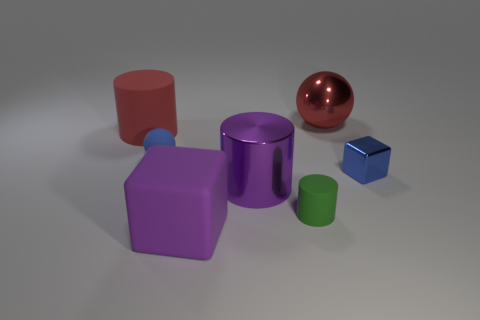Is the material of the big red cylinder the same as the blue block that is behind the big purple rubber thing?
Give a very brief answer. No. What number of objects are blue objects to the left of the large metallic ball or blue objects that are to the left of the big purple metal thing?
Your answer should be very brief. 1. What number of other objects are the same color as the big cube?
Offer a terse response. 1. Are there more green matte cylinders that are to the left of the small sphere than tiny matte cylinders that are on the right side of the small green rubber cylinder?
Your answer should be compact. No. Is there anything else that is the same size as the blue sphere?
Your answer should be very brief. Yes. How many cubes are either small things or tiny matte things?
Provide a succinct answer. 1. What number of objects are either purple things that are behind the big matte cube or tiny metal objects?
Give a very brief answer. 2. What shape is the large red thing left of the metal object behind the big object on the left side of the rubber ball?
Your answer should be compact. Cylinder. What number of blue things are the same shape as the large red metallic thing?
Your answer should be very brief. 1. What is the material of the tiny sphere that is the same color as the metal cube?
Offer a very short reply. Rubber. 